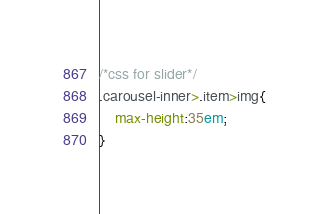<code> <loc_0><loc_0><loc_500><loc_500><_CSS_>
/*css for slider*/
.carousel-inner>.item>img{
	max-height:35em;
}</code> 